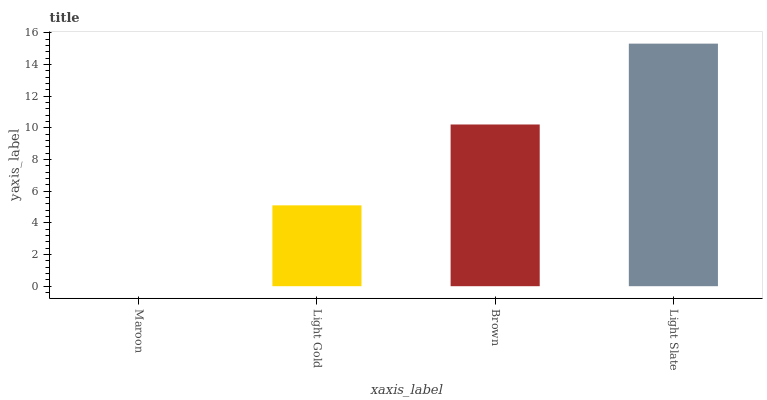Is Maroon the minimum?
Answer yes or no. Yes. Is Light Slate the maximum?
Answer yes or no. Yes. Is Light Gold the minimum?
Answer yes or no. No. Is Light Gold the maximum?
Answer yes or no. No. Is Light Gold greater than Maroon?
Answer yes or no. Yes. Is Maroon less than Light Gold?
Answer yes or no. Yes. Is Maroon greater than Light Gold?
Answer yes or no. No. Is Light Gold less than Maroon?
Answer yes or no. No. Is Brown the high median?
Answer yes or no. Yes. Is Light Gold the low median?
Answer yes or no. Yes. Is Light Slate the high median?
Answer yes or no. No. Is Light Slate the low median?
Answer yes or no. No. 